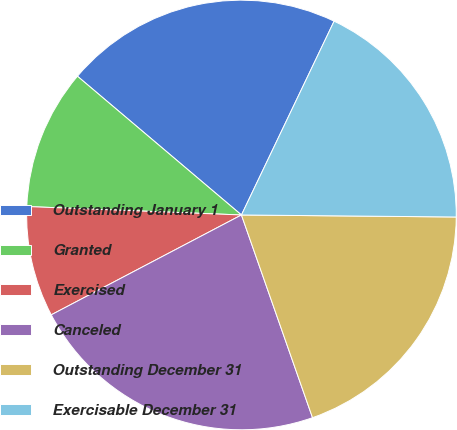<chart> <loc_0><loc_0><loc_500><loc_500><pie_chart><fcel>Outstanding January 1<fcel>Granted<fcel>Exercised<fcel>Canceled<fcel>Outstanding December 31<fcel>Exercisable December 31<nl><fcel>20.92%<fcel>10.55%<fcel>8.32%<fcel>22.67%<fcel>19.48%<fcel>18.05%<nl></chart> 